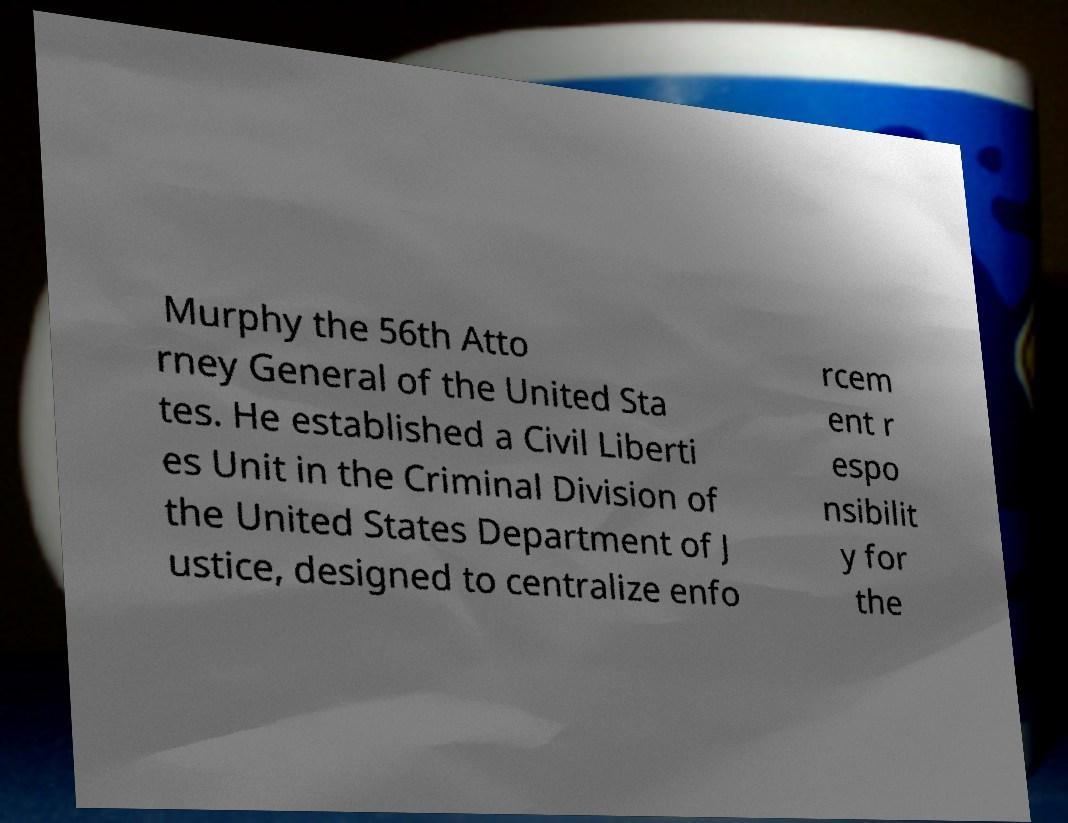What messages or text are displayed in this image? I need them in a readable, typed format. Murphy the 56th Atto rney General of the United Sta tes. He established a Civil Liberti es Unit in the Criminal Division of the United States Department of J ustice, designed to centralize enfo rcem ent r espo nsibilit y for the 